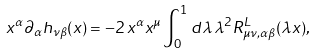<formula> <loc_0><loc_0><loc_500><loc_500>x ^ { \alpha } \partial _ { \alpha } h _ { \nu \beta } ( x ) = - 2 \, x ^ { \alpha } x ^ { \mu } \int ^ { 1 } _ { 0 } d \lambda \, \lambda ^ { 2 } R ^ { L } _ { \mu \nu , \alpha \beta } ( \lambda x ) ,</formula> 